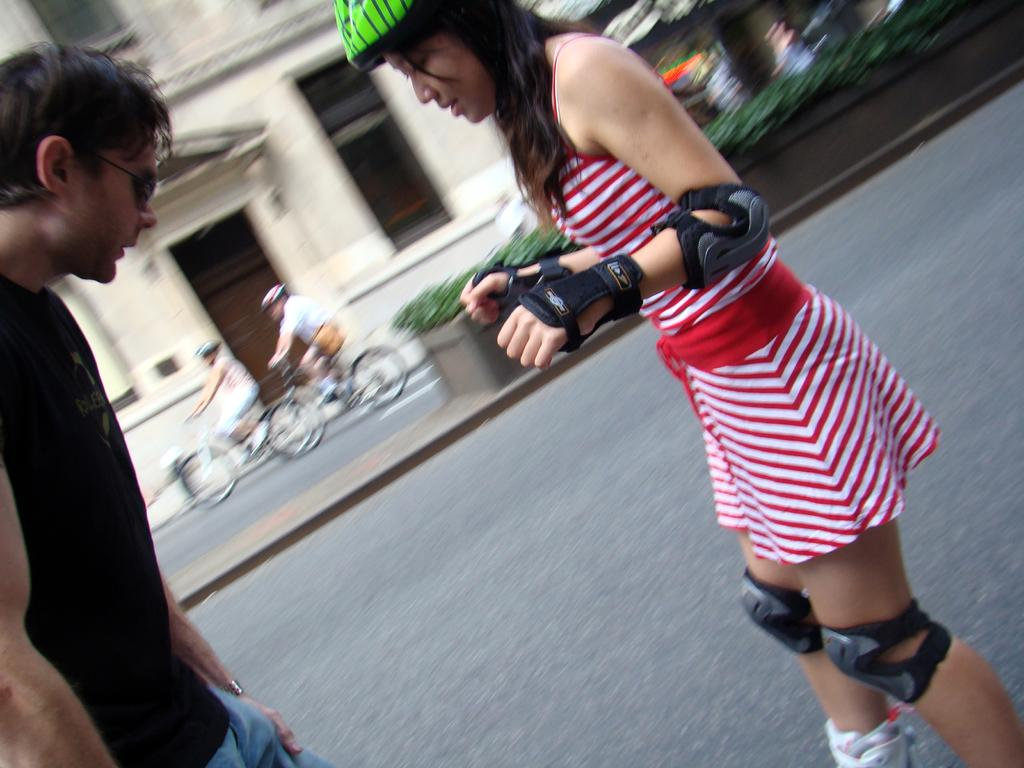Who can be seen in the image? There are people in the image. What are some of the people doing in the image? Some of the people are riding bicycles on the road. What can be seen in the background of the image? There is a building with windows and plants visible in the background. What does the mom say to the man during the earthquake in the image? There is no mention of a mom, a man, or an earthquake in the image. 